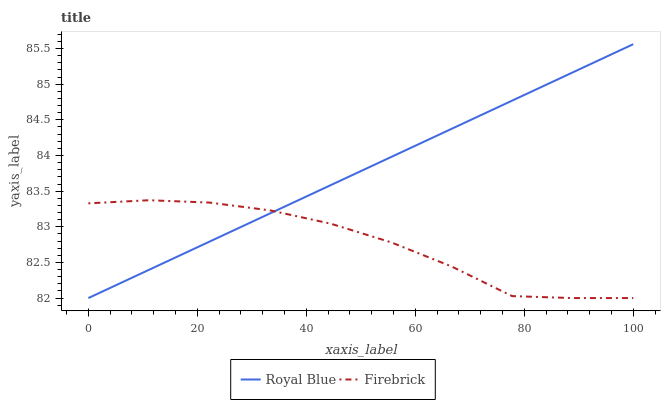Does Firebrick have the minimum area under the curve?
Answer yes or no. Yes. Does Royal Blue have the maximum area under the curve?
Answer yes or no. Yes. Does Firebrick have the maximum area under the curve?
Answer yes or no. No. Is Royal Blue the smoothest?
Answer yes or no. Yes. Is Firebrick the roughest?
Answer yes or no. Yes. Is Firebrick the smoothest?
Answer yes or no. No. Does Royal Blue have the lowest value?
Answer yes or no. Yes. Does Royal Blue have the highest value?
Answer yes or no. Yes. Does Firebrick have the highest value?
Answer yes or no. No. Does Royal Blue intersect Firebrick?
Answer yes or no. Yes. Is Royal Blue less than Firebrick?
Answer yes or no. No. Is Royal Blue greater than Firebrick?
Answer yes or no. No. 